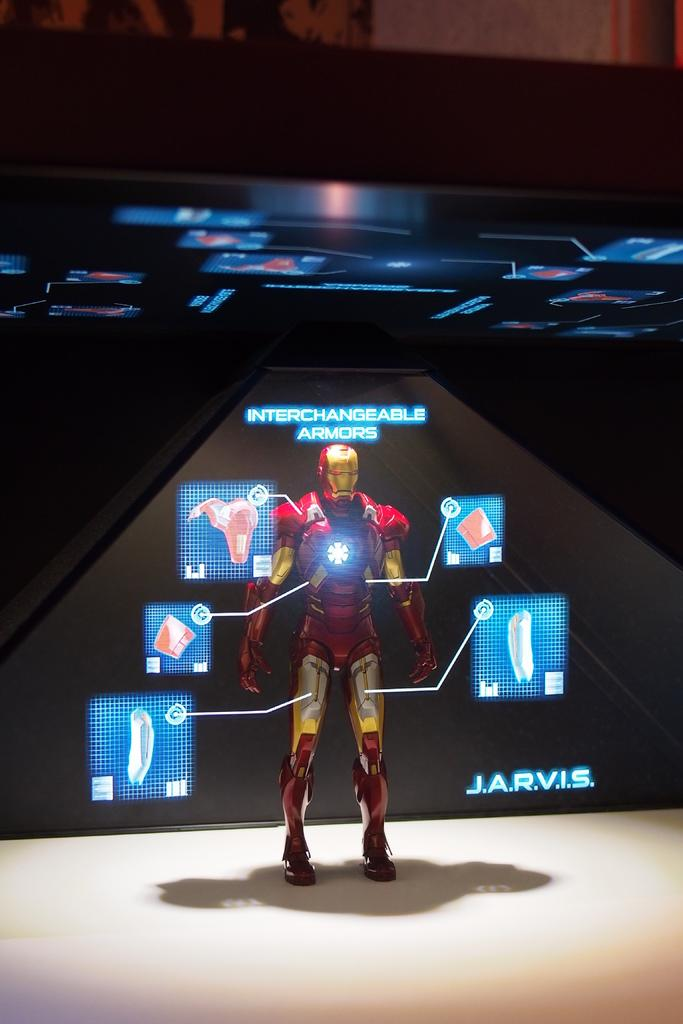<image>
Give a short and clear explanation of the subsequent image. An Iron Man suit is on display and it says J.A.R.V.I.S. 